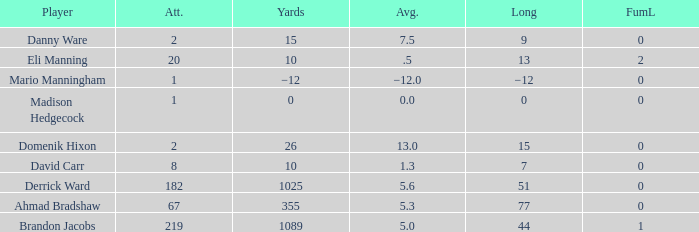What is Domenik Hixon's average rush? 13.0. 